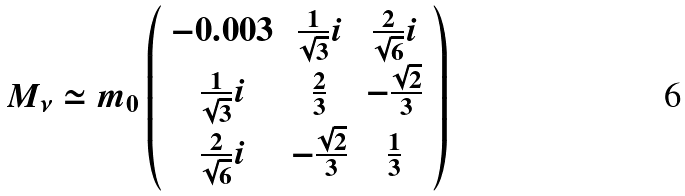<formula> <loc_0><loc_0><loc_500><loc_500>M _ { \nu } \simeq m _ { 0 } \left ( \begin{array} { c c c } { - 0 . 0 0 3 } & { { \frac { 1 } { \sqrt { 3 } } i } } & { { \frac { 2 } { \sqrt { 6 } } i } } \\ { { \frac { 1 } { \sqrt { 3 } } i } } & { { \frac { 2 } { 3 } } } & { { - \frac { \sqrt { 2 } } { 3 } } } \\ { { \frac { 2 } { \sqrt { 6 } } i } } & { { - \frac { \sqrt { 2 } } { 3 } } } & { { \frac { 1 } { 3 } } } \end{array} \right )</formula> 